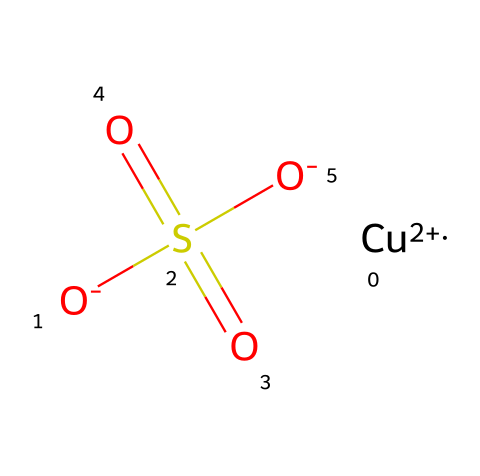What is the central metal ion in this coordination compound? The chemical structure shows a copper ion represented by [Cu+2], which indicates that copper is the central metal ion.
Answer: copper How many oxygen atoms are present in this compound? The SMILES representation includes three oxygen atoms: two from the sulfate group (SO4) and one from the deprotonated hydroxyl (O-).
Answer: three What is the charge of the central copper ion? The notation [Cu+2] shows that the copper ion has a +2 charge.
Answer: +2 Which chemical group is indicated by "S(=O)(=O)" in this structure? The notation indicates a sulfate group (SO4) due to the sulfur atom bonded to four oxygen atoms with two double bonds and two single bonds.
Answer: sulfate What type of complex is formed in this coordination compound? The coordination compound describes a complex that includes a metal ion (copper) bonded to a sulfate ion, creating a coordination complex.
Answer: coordination complex How does the structure indicate the presence of a bidentate ligand? The sulfate ion (SO4) can act as a bidentate ligand because it can coordinate to the copper ion through different oxygen atoms, forming multiple bonds.
Answer: bidentate ligand Is this compound likely to be soluble in water? The presence of ionic components like the sulfate and copper suggests that this coordination compound is likely to be soluble in water due to the ionic nature of the bonds.
Answer: likely 